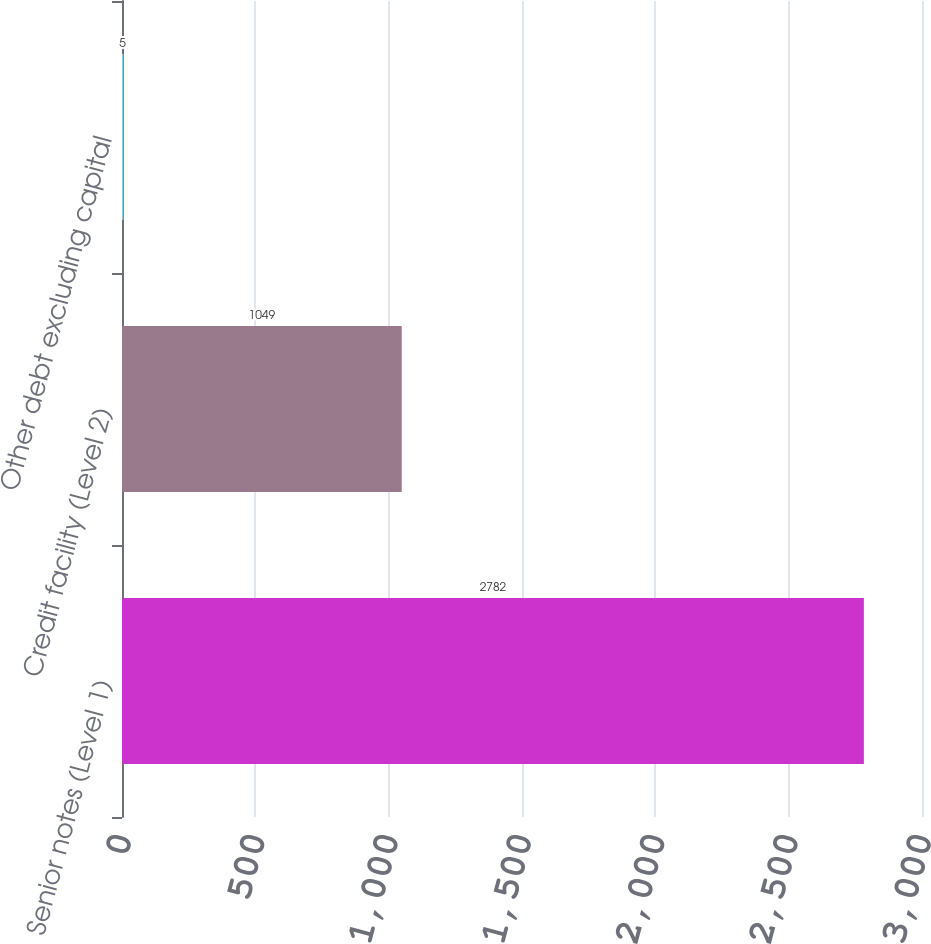Convert chart. <chart><loc_0><loc_0><loc_500><loc_500><bar_chart><fcel>Senior notes (Level 1)<fcel>Credit facility (Level 2)<fcel>Other debt excluding capital<nl><fcel>2782<fcel>1049<fcel>5<nl></chart> 